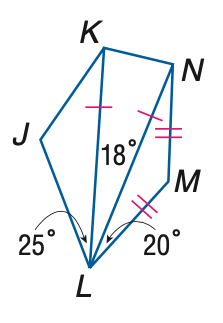Answer the mathemtical geometry problem and directly provide the correct option letter.
Question: \triangle K L N and \triangle L M N are isosceles and m \angle J K N = 130. Find the measure of \angle L K N.
Choices: A: 75 B: 78 C: 79 D: 81 D 